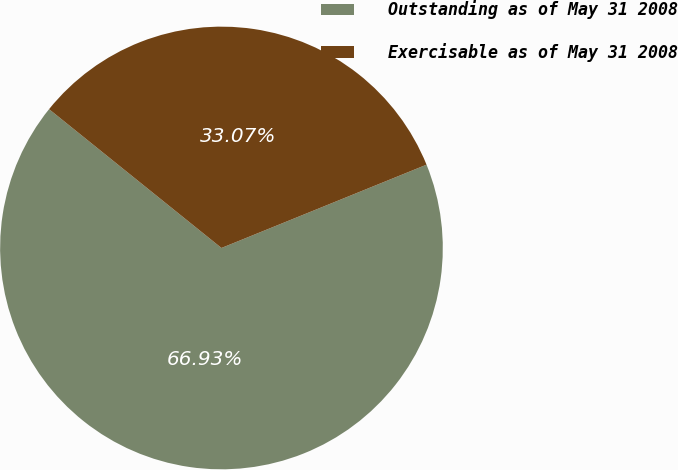<chart> <loc_0><loc_0><loc_500><loc_500><pie_chart><fcel>Outstanding as of May 31 2008<fcel>Exercisable as of May 31 2008<nl><fcel>66.93%<fcel>33.07%<nl></chart> 